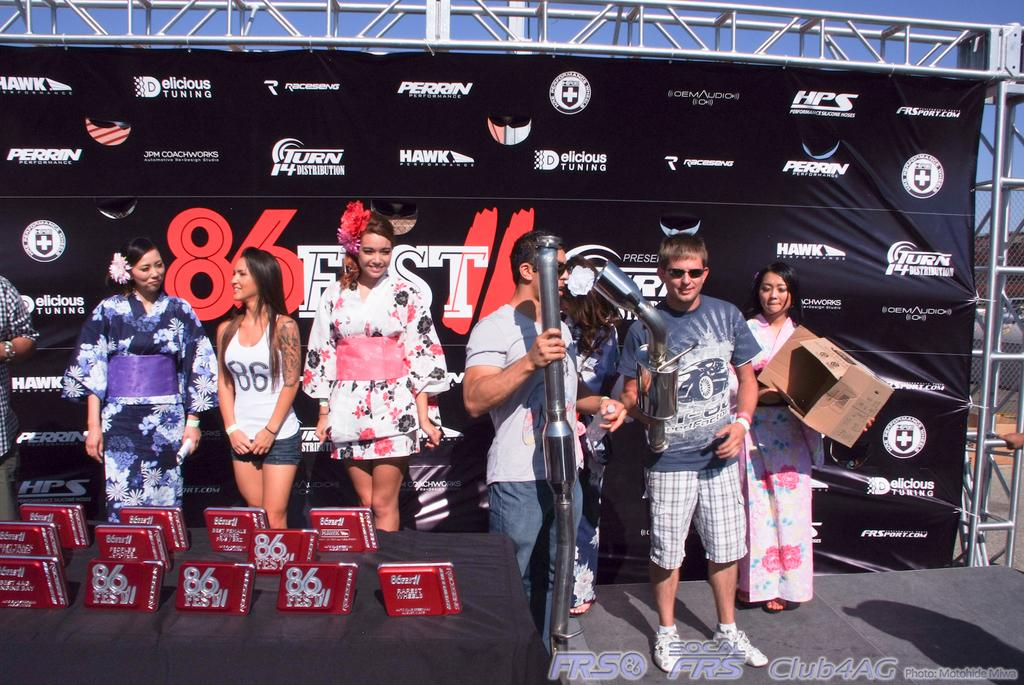Provide a one-sentence caption for the provided image. A diverse group of people hang around a table laden with 86 Fest merchandise. 